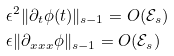<formula> <loc_0><loc_0><loc_500><loc_500>& \epsilon ^ { 2 } \| \partial _ { t } \phi ( t ) \| _ { s - 1 } = O ( \mathcal { E } _ { s } ) \\ & \epsilon \| \partial _ { x x x } \phi \| _ { s - 1 } = O ( \mathcal { E } _ { s } )</formula> 